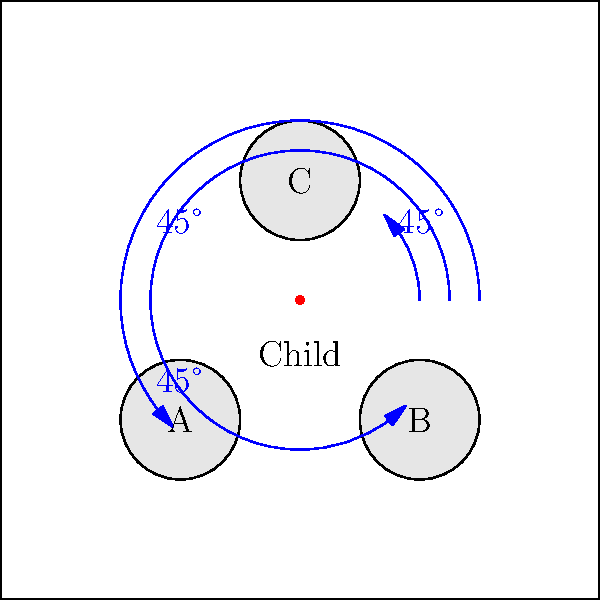In a pediatric audiology testing room, three pieces of equipment (A, B, and C) are arranged around a child as shown in the diagram. The child is positioned at the center, and each piece of equipment is placed at a 45° angle from the adjacent equipment. If the distance between the child and equipment A is 28 cm, and the distance between equipment A and B is 40 cm, what is the distance between the child and equipment C? Let's approach this step-by-step:

1) First, we need to recognize that the arrangement forms an isosceles right triangle, with the child at the right angle and equipment A and B at the other corners.

2) In an isosceles right triangle, the two non-right angles are each 45°, and the two sides adjacent to the right angle are equal.

3) We're given that the distance from the child to A is 28 cm. Due to the properties of an isosceles right triangle, this is also the distance from the child to B.

4) We can use the Pythagorean theorem to find the distance from A to B:

   $AB^2 = 28^2 + 28^2 = 1568$
   $AB = \sqrt{1568} = 39.6$ cm (which rounds to the given 40 cm)

5) Now, we need to find the distance to C. The arrangement of the child, A, and C also forms an isosceles right triangle, identical to the one formed by the child, A, and B.

6) In this new triangle, we know one side (child to A) is 28 cm. The distance from the child to C will be the same.

Therefore, the distance from the child to equipment C is 28 cm.
Answer: 28 cm 